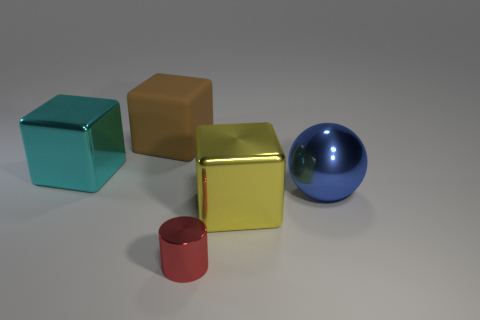There is a cyan thing that is the same shape as the yellow thing; what is its material?
Make the answer very short. Metal. There is a thing that is both to the left of the blue sphere and on the right side of the small cylinder; what shape is it?
Provide a short and direct response. Cube. What shape is the big yellow object in front of the brown matte block?
Offer a very short reply. Cube. How many things are right of the yellow block and behind the cyan shiny cube?
Provide a succinct answer. 0. There is a blue object; is it the same size as the block in front of the large cyan metal block?
Ensure brevity in your answer.  Yes. How big is the shiny object to the right of the large metallic thing in front of the large thing to the right of the big yellow cube?
Ensure brevity in your answer.  Large. There is a object left of the brown thing; what is its size?
Keep it short and to the point. Large. What is the shape of the big blue thing that is the same material as the red thing?
Make the answer very short. Sphere. Is the large block to the right of the small metallic cylinder made of the same material as the tiny cylinder?
Provide a short and direct response. Yes. What number of other objects are there of the same material as the large blue ball?
Your answer should be compact. 3. 